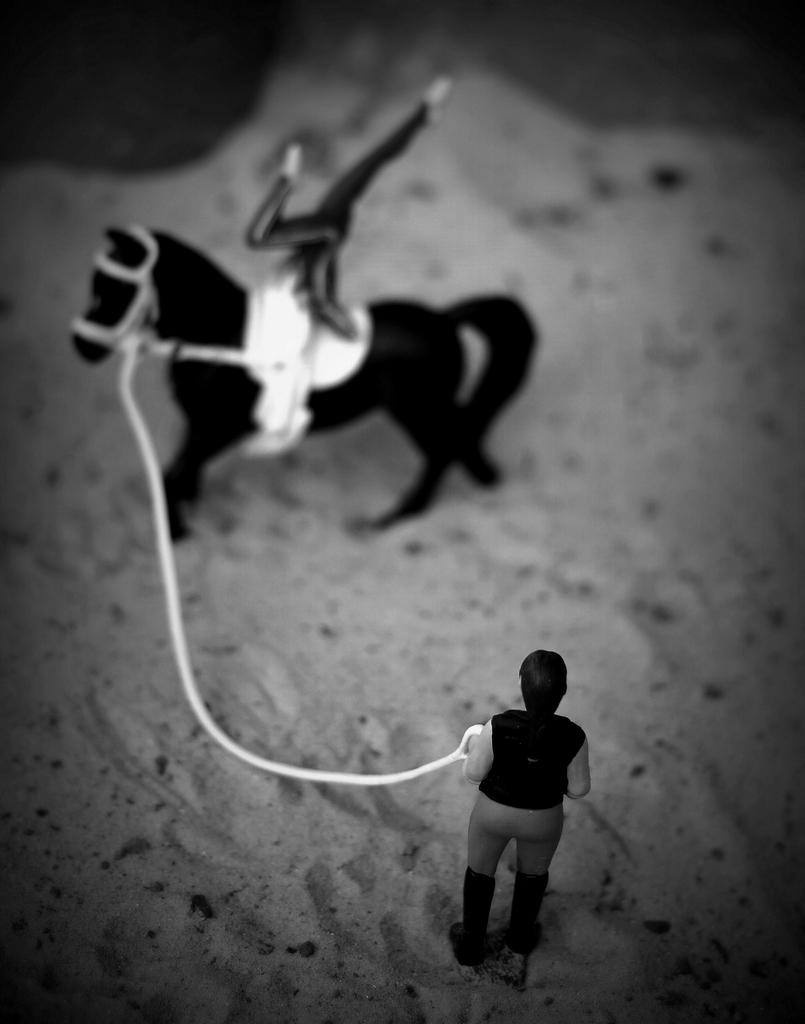What type of surface is visible in the image? There is sand in the image. What type of toy can be seen in the image? There is a black color toy horse in the image. What is the toy man holding in the image? There is a toy man holding a rope in the image. What type of food is the carpenter eating in the image? There is no carpenter or food present in the image. What type of furniture can be seen in the image? There is no furniture present in the image. 